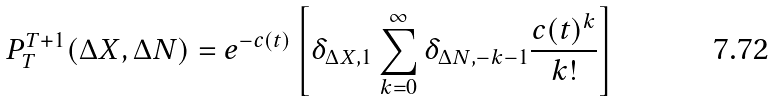<formula> <loc_0><loc_0><loc_500><loc_500>P ^ { T + 1 } _ { T } ( \Delta X , \Delta N ) = e ^ { - c ( t ) } \left [ \delta _ { \Delta X , 1 } \sum _ { k = 0 } ^ { \infty } \delta _ { \Delta N , - k - 1 } \frac { c ( t ) ^ { k } } { k ! } \right ]</formula> 